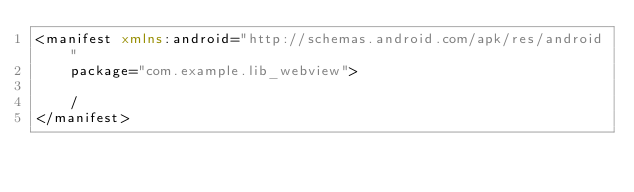Convert code to text. <code><loc_0><loc_0><loc_500><loc_500><_XML_><manifest xmlns:android="http://schemas.android.com/apk/res/android"
    package="com.example.lib_webview">

    /
</manifest></code> 